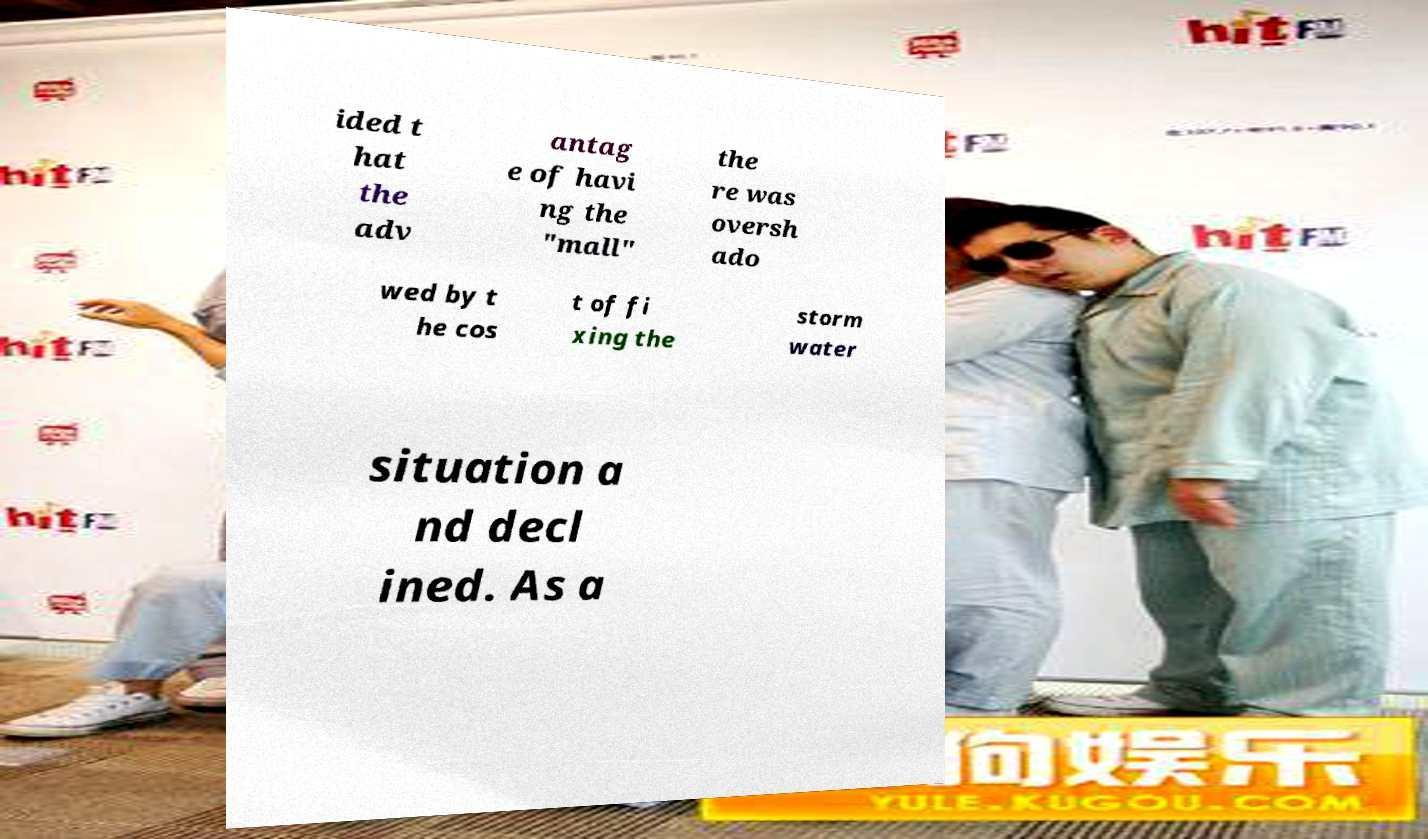There's text embedded in this image that I need extracted. Can you transcribe it verbatim? ided t hat the adv antag e of havi ng the "mall" the re was oversh ado wed by t he cos t of fi xing the storm water situation a nd decl ined. As a 